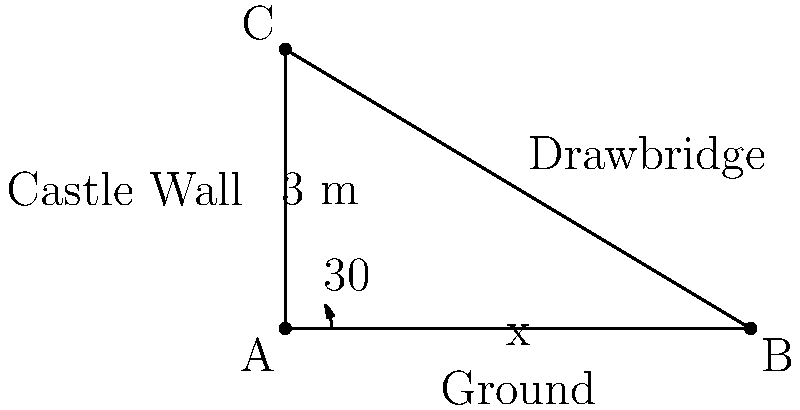In a medieval castle, a drawbridge forms a 30° angle with the ground when lowered. If the castle wall is 3 meters high, what is the length of the drawbridge to the nearest tenth of a meter? Let's approach this step-by-step using trigonometry:

1) We can see that this forms a right-angled triangle, where:
   - The castle wall is the opposite side (3 meters)
   - The drawbridge is the hypotenuse (let's call this x)
   - The angle between the ground and drawbridge is 30°

2) In a right-angled triangle, we can use the sine function:

   $\sin(\theta) = \frac{\text{opposite}}{\text{hypotenuse}}$

3) Plugging in our values:

   $\sin(30°) = \frac{3}{x}$

4) We know that $\sin(30°) = \frac{1}{2}$, so:

   $\frac{1}{2} = \frac{3}{x}$

5) Cross multiply:

   $x \cdot \frac{1}{2} = 3$

6) Solve for x:

   $x = 3 \cdot 2 = 6$

7) Therefore, the length of the drawbridge is 6 meters.
Answer: 6.0 m 